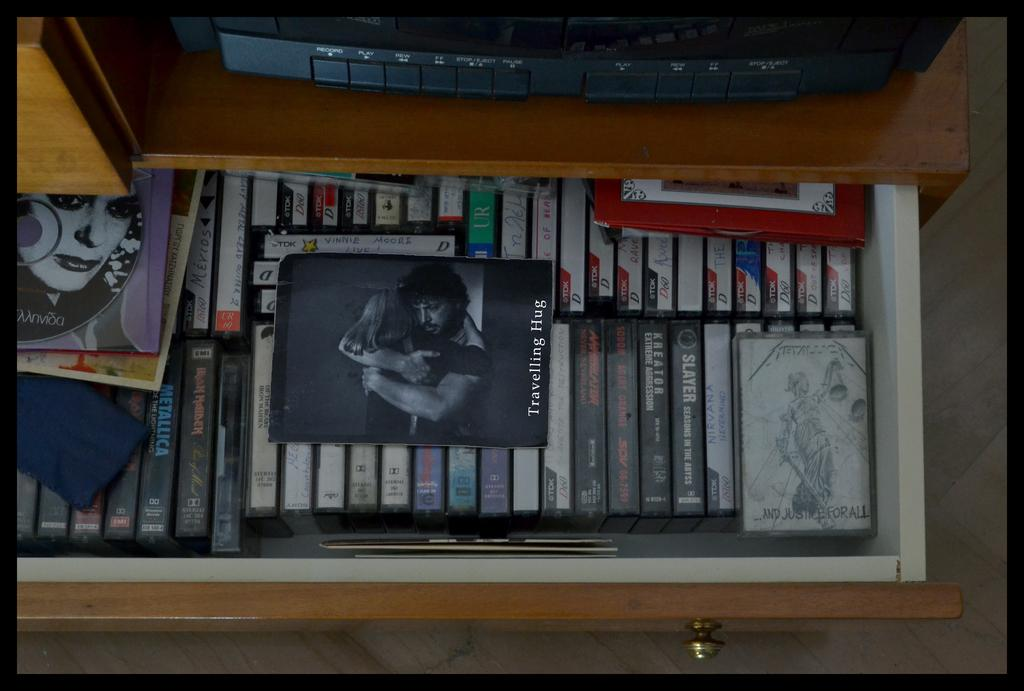<image>
Provide a brief description of the given image. A drawer full of movies is pulled out and has "Traveling Hugs" sitting on top of the other movies. 